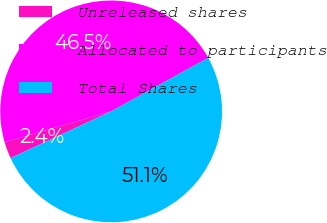Convert chart. <chart><loc_0><loc_0><loc_500><loc_500><pie_chart><fcel>Unreleased shares<fcel>Allocated to participants<fcel>Total Shares<nl><fcel>2.44%<fcel>46.46%<fcel>51.1%<nl></chart> 